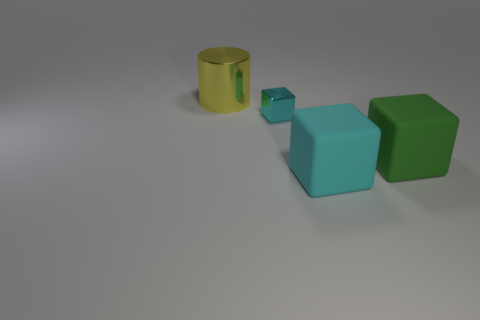Add 3 cyan objects. How many objects exist? 7 Subtract all large cyan rubber cubes. How many cubes are left? 2 Subtract all cubes. How many objects are left? 1 Subtract all yellow metal cylinders. Subtract all green rubber cubes. How many objects are left? 2 Add 3 green blocks. How many green blocks are left? 4 Add 4 red matte balls. How many red matte balls exist? 4 Subtract 0 purple cylinders. How many objects are left? 4 